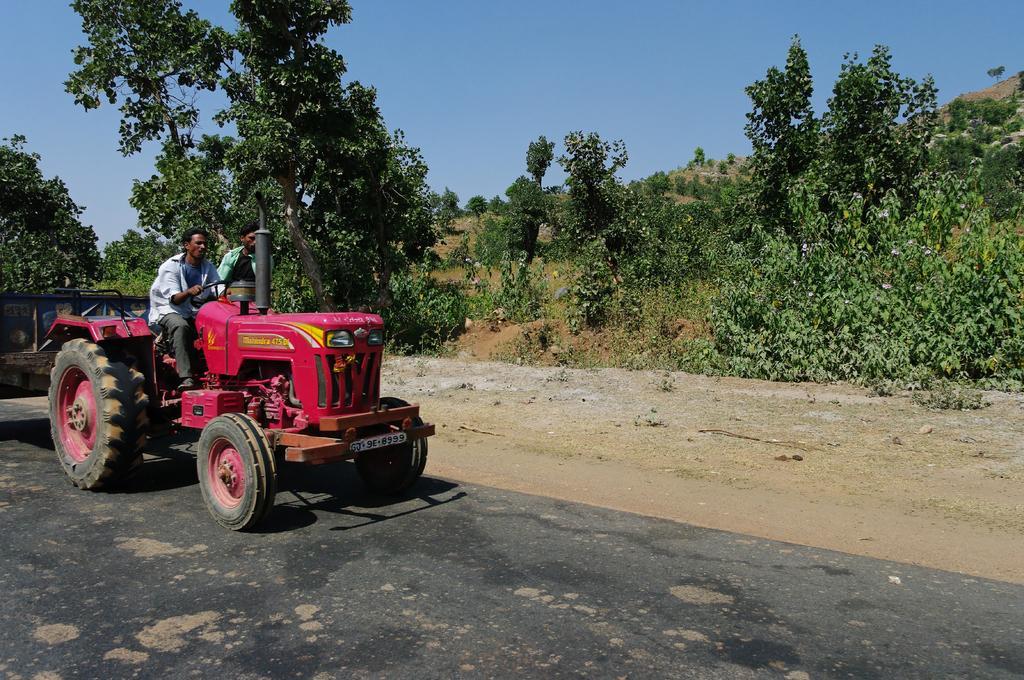How would you summarize this image in a sentence or two? In this image on the left side I can see a vehicle and on the vehicle I can see two persons visible on road, in the middle there are trees, some trees visible on the hill on the right side,at the top there is the sky visible. 